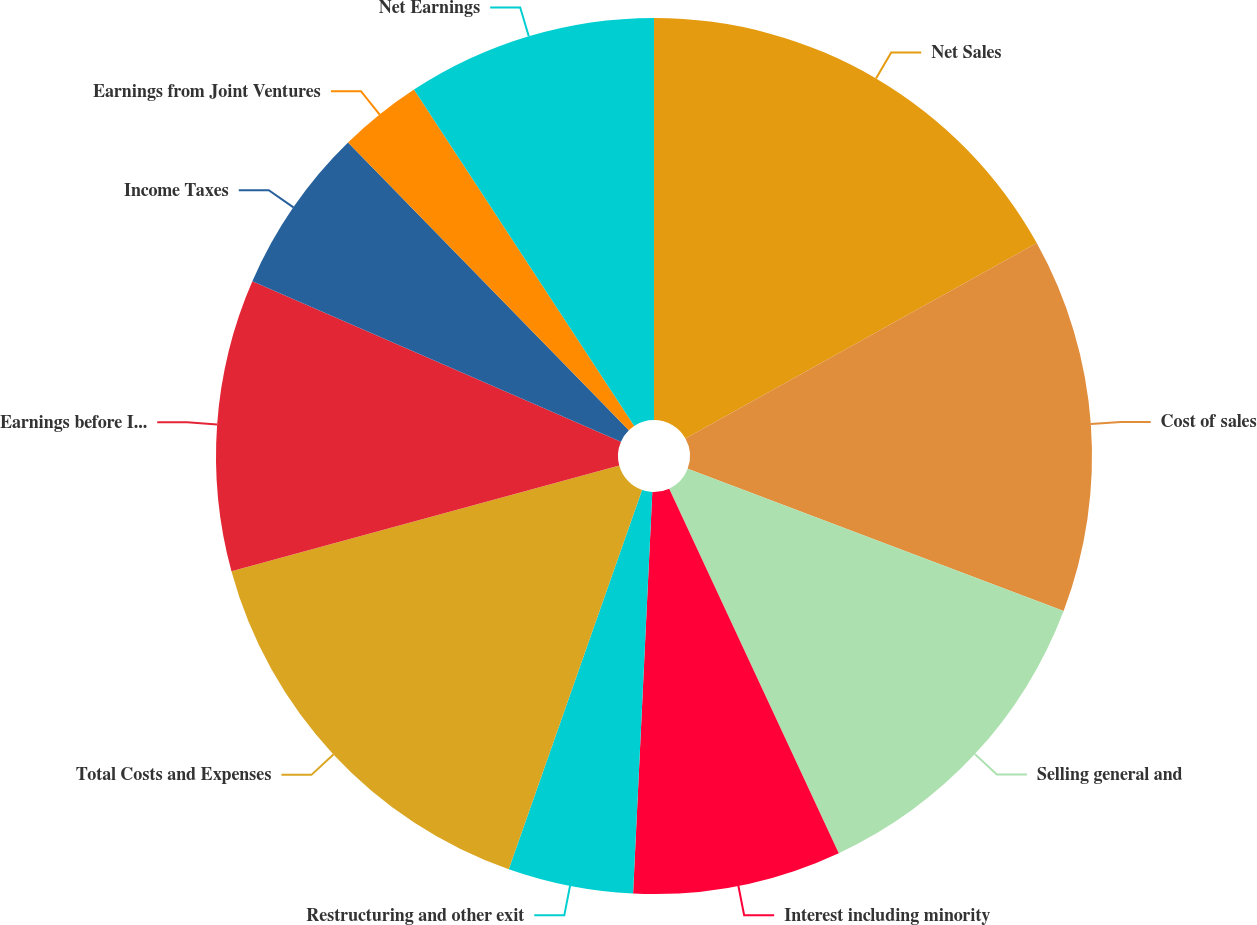Convert chart. <chart><loc_0><loc_0><loc_500><loc_500><pie_chart><fcel>Net Sales<fcel>Cost of sales<fcel>Selling general and<fcel>Interest including minority<fcel>Restructuring and other exit<fcel>Total Costs and Expenses<fcel>Earnings before Income Taxes<fcel>Income Taxes<fcel>Earnings from Joint Ventures<fcel>Net Earnings<nl><fcel>16.92%<fcel>13.84%<fcel>12.31%<fcel>7.69%<fcel>4.62%<fcel>15.38%<fcel>10.77%<fcel>6.16%<fcel>3.08%<fcel>9.23%<nl></chart> 